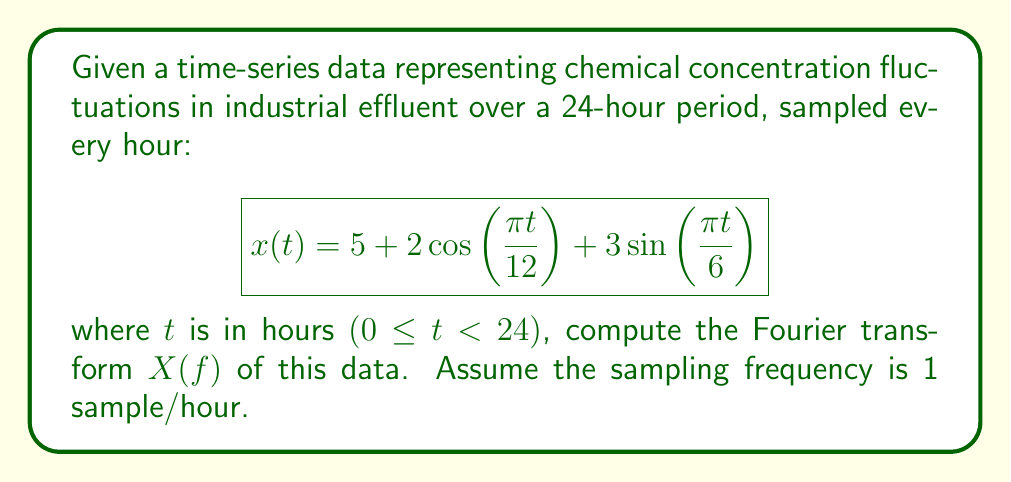Help me with this question. To compute the Fourier transform of the given time-series data, we'll follow these steps:

1) The general form of the Fourier transform is:

   $$ X(f) = \int_{-\infty}^{\infty} x(t) e^{-i2\pi ft} dt $$

2) Our signal $x(t)$ consists of three components:
   - A constant term: 5
   - A cosine term: $2\cos(\frac{\pi t}{12})$
   - A sine term: $3\sin(\frac{\pi t}{6})$

3) For the constant term:
   $$ \mathcal{F}\{5\} = 5\delta(f) $$
   where $\delta(f)$ is the Dirac delta function.

4) For the cosine term:
   $$ \mathcal{F}\{2\cos(\frac{\pi t}{12})\} = \delta(f - \frac{1}{24}) + \delta(f + \frac{1}{24}) $$

5) For the sine term:
   $$ \mathcal{F}\{3\sin(\frac{\pi t}{6})\} = -\frac{3i}{2}\delta(f - \frac{1}{12}) + \frac{3i}{2}\delta(f + \frac{1}{12}) $$

6) Combining these results, we get:

   $$ X(f) = 5\delta(f) + \delta(f - \frac{1}{24}) + \delta(f + \frac{1}{24}) - \frac{3i}{2}\delta(f - \frac{1}{12}) + \frac{3i}{2}\delta(f + \frac{1}{12}) $$

7) Note that the Fourier transform is symmetric around f = 0, and the sampling frequency (1 sample/hour) determines the range of frequencies we can resolve.
Answer: $$ X(f) = 5\delta(f) + \delta(f - \frac{1}{24}) + \delta(f + \frac{1}{24}) - \frac{3i}{2}\delta(f - \frac{1}{12}) + \frac{3i}{2}\delta(f + \frac{1}{12}) $$ 